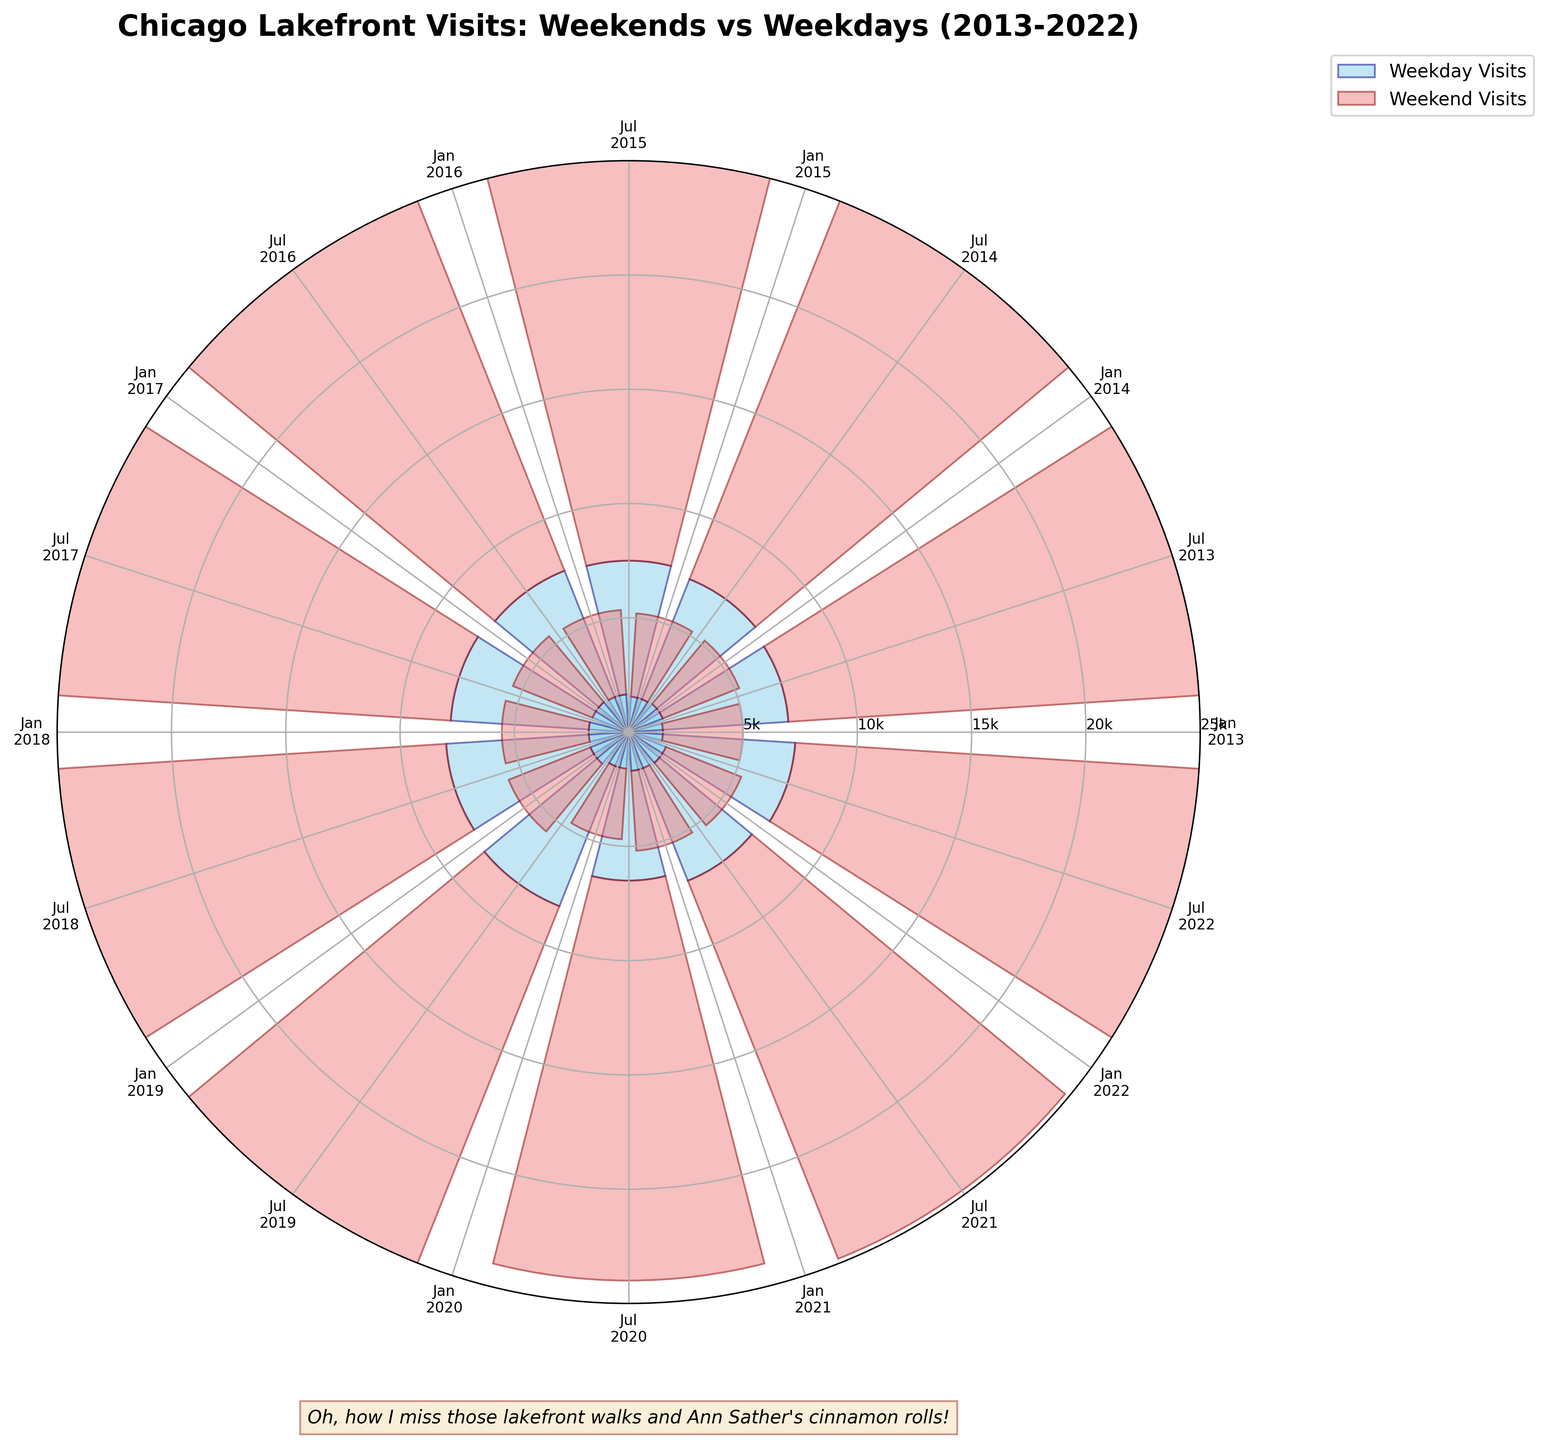What months are represented in the figure? The figure labels indicate "Jan" and "Jul" for each year from 2013 to 2022.
Answer: January and July How many years of data are plotted in the figure? The figure spans from 2013 to 2022, which is 10 years.
Answer: 10 years What color represents weekday visits? Weekday visits are represented by skyblue bars with navy edges in the figure.
Answer: Skyblue Which year saw the highest number of weekend visits in July? In July, 2019 has the highest weekend visits with a bar reaching the 20000 visits mark.
Answer: 2019 How do the weekend visits compare to weekday visits on average? On average, weekend visits are consistently higher than weekday visits.
Answer: Weekend visits are higher In which year did January have the lowest number of visits? January 2020 had the lowest visits with approximately 1600 weekday and 3100 weekend visits.
Answer: 2020 Which year and month combination had the closest weekend and weekday visits? January 2013 had the closest, with 1500 weekday and 3500 weekend visits, a smaller gap compared to other combinations.
Answer: January 2013 How do the trends in visits show the impact of seasons? The data show significantly higher visits in July compared to January, illustrating a seasonal trend likely due to Chicago's colder winter weather in January.
Answer: More visits in July What is the difference in weekend visits between July 2016 and January 2022? July 2016 had approximately 19200 weekend visits, while January 2022 had about 3550 weekend visits. The difference is 19200 - 3550 = 15650.
Answer: 15650 How did the pandemic year, 2020, compare to others in terms of visits? Both January and July of 2020 saw a decrease in visits compared to previous years, reflecting the impact of the pandemic.
Answer: Decrease in visits 